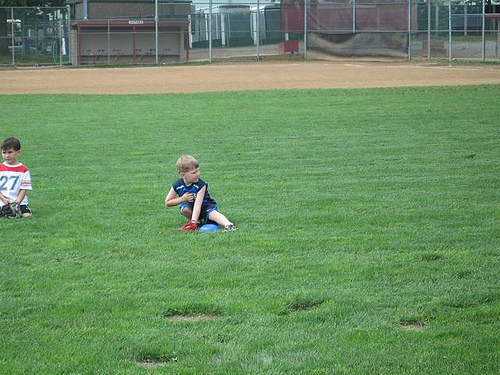Please extract the text content from this image. 2 7 